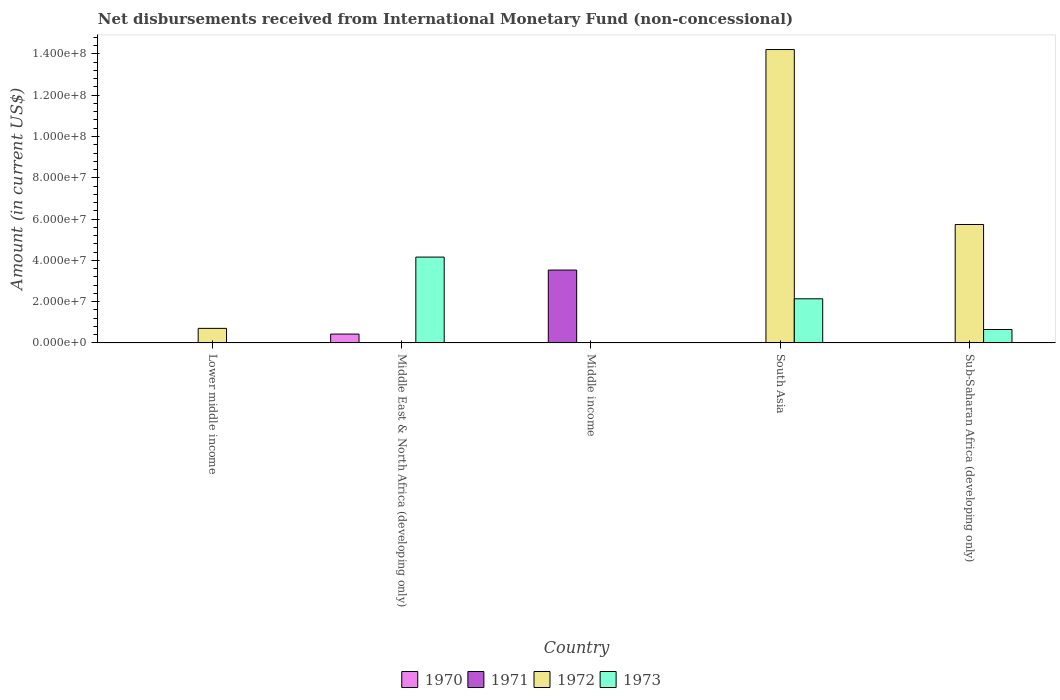How many different coloured bars are there?
Make the answer very short. 4. Are the number of bars on each tick of the X-axis equal?
Provide a short and direct response. No. How many bars are there on the 1st tick from the right?
Provide a succinct answer. 2. What is the label of the 2nd group of bars from the left?
Your response must be concise. Middle East & North Africa (developing only). Across all countries, what is the maximum amount of disbursements received from International Monetary Fund in 1972?
Provide a short and direct response. 1.42e+08. What is the total amount of disbursements received from International Monetary Fund in 1973 in the graph?
Make the answer very short. 6.95e+07. What is the difference between the amount of disbursements received from International Monetary Fund in 1972 in South Asia and that in Sub-Saharan Africa (developing only)?
Ensure brevity in your answer.  8.48e+07. What is the difference between the amount of disbursements received from International Monetary Fund in 1972 in South Asia and the amount of disbursements received from International Monetary Fund in 1970 in Middle income?
Provide a short and direct response. 1.42e+08. What is the average amount of disbursements received from International Monetary Fund in 1971 per country?
Your answer should be very brief. 7.06e+06. What is the difference between the amount of disbursements received from International Monetary Fund of/in 1973 and amount of disbursements received from International Monetary Fund of/in 1970 in Middle East & North Africa (developing only)?
Make the answer very short. 3.73e+07. Is the amount of disbursements received from International Monetary Fund in 1973 in Middle East & North Africa (developing only) less than that in South Asia?
Provide a succinct answer. No. What is the difference between the highest and the second highest amount of disbursements received from International Monetary Fund in 1972?
Give a very brief answer. 8.48e+07. What is the difference between the highest and the lowest amount of disbursements received from International Monetary Fund in 1972?
Provide a succinct answer. 1.42e+08. Is the sum of the amount of disbursements received from International Monetary Fund in 1972 in Lower middle income and South Asia greater than the maximum amount of disbursements received from International Monetary Fund in 1973 across all countries?
Your response must be concise. Yes. Is it the case that in every country, the sum of the amount of disbursements received from International Monetary Fund in 1971 and amount of disbursements received from International Monetary Fund in 1973 is greater than the sum of amount of disbursements received from International Monetary Fund in 1972 and amount of disbursements received from International Monetary Fund in 1970?
Keep it short and to the point. No. Is it the case that in every country, the sum of the amount of disbursements received from International Monetary Fund in 1972 and amount of disbursements received from International Monetary Fund in 1973 is greater than the amount of disbursements received from International Monetary Fund in 1971?
Give a very brief answer. No. How many bars are there?
Your response must be concise. 8. What is the difference between two consecutive major ticks on the Y-axis?
Offer a very short reply. 2.00e+07. Are the values on the major ticks of Y-axis written in scientific E-notation?
Your answer should be very brief. Yes. Does the graph contain any zero values?
Offer a very short reply. Yes. What is the title of the graph?
Make the answer very short. Net disbursements received from International Monetary Fund (non-concessional). Does "1966" appear as one of the legend labels in the graph?
Your response must be concise. No. What is the label or title of the X-axis?
Give a very brief answer. Country. What is the Amount (in current US$) in 1970 in Lower middle income?
Offer a very short reply. 0. What is the Amount (in current US$) in 1971 in Lower middle income?
Your answer should be very brief. 0. What is the Amount (in current US$) of 1972 in Lower middle income?
Ensure brevity in your answer.  7.06e+06. What is the Amount (in current US$) of 1973 in Lower middle income?
Your answer should be very brief. 0. What is the Amount (in current US$) of 1970 in Middle East & North Africa (developing only)?
Your response must be concise. 4.30e+06. What is the Amount (in current US$) of 1973 in Middle East & North Africa (developing only)?
Offer a terse response. 4.16e+07. What is the Amount (in current US$) of 1970 in Middle income?
Provide a short and direct response. 0. What is the Amount (in current US$) of 1971 in Middle income?
Offer a very short reply. 3.53e+07. What is the Amount (in current US$) of 1973 in Middle income?
Your answer should be compact. 0. What is the Amount (in current US$) in 1971 in South Asia?
Your answer should be compact. 0. What is the Amount (in current US$) of 1972 in South Asia?
Offer a very short reply. 1.42e+08. What is the Amount (in current US$) in 1973 in South Asia?
Provide a succinct answer. 2.14e+07. What is the Amount (in current US$) of 1972 in Sub-Saharan Africa (developing only)?
Keep it short and to the point. 5.74e+07. What is the Amount (in current US$) in 1973 in Sub-Saharan Africa (developing only)?
Your answer should be very brief. 6.51e+06. Across all countries, what is the maximum Amount (in current US$) in 1970?
Give a very brief answer. 4.30e+06. Across all countries, what is the maximum Amount (in current US$) of 1971?
Offer a terse response. 3.53e+07. Across all countries, what is the maximum Amount (in current US$) of 1972?
Make the answer very short. 1.42e+08. Across all countries, what is the maximum Amount (in current US$) of 1973?
Provide a succinct answer. 4.16e+07. Across all countries, what is the minimum Amount (in current US$) in 1970?
Provide a short and direct response. 0. Across all countries, what is the minimum Amount (in current US$) of 1972?
Provide a short and direct response. 0. Across all countries, what is the minimum Amount (in current US$) in 1973?
Give a very brief answer. 0. What is the total Amount (in current US$) in 1970 in the graph?
Give a very brief answer. 4.30e+06. What is the total Amount (in current US$) in 1971 in the graph?
Make the answer very short. 3.53e+07. What is the total Amount (in current US$) of 1972 in the graph?
Provide a short and direct response. 2.07e+08. What is the total Amount (in current US$) in 1973 in the graph?
Give a very brief answer. 6.95e+07. What is the difference between the Amount (in current US$) of 1972 in Lower middle income and that in South Asia?
Make the answer very short. -1.35e+08. What is the difference between the Amount (in current US$) of 1972 in Lower middle income and that in Sub-Saharan Africa (developing only)?
Give a very brief answer. -5.03e+07. What is the difference between the Amount (in current US$) of 1973 in Middle East & North Africa (developing only) and that in South Asia?
Offer a terse response. 2.02e+07. What is the difference between the Amount (in current US$) in 1973 in Middle East & North Africa (developing only) and that in Sub-Saharan Africa (developing only)?
Provide a succinct answer. 3.51e+07. What is the difference between the Amount (in current US$) of 1972 in South Asia and that in Sub-Saharan Africa (developing only)?
Provide a succinct answer. 8.48e+07. What is the difference between the Amount (in current US$) of 1973 in South Asia and that in Sub-Saharan Africa (developing only)?
Provide a short and direct response. 1.49e+07. What is the difference between the Amount (in current US$) in 1972 in Lower middle income and the Amount (in current US$) in 1973 in Middle East & North Africa (developing only)?
Offer a very short reply. -3.45e+07. What is the difference between the Amount (in current US$) of 1972 in Lower middle income and the Amount (in current US$) of 1973 in South Asia?
Make the answer very short. -1.43e+07. What is the difference between the Amount (in current US$) in 1972 in Lower middle income and the Amount (in current US$) in 1973 in Sub-Saharan Africa (developing only)?
Your answer should be very brief. 5.46e+05. What is the difference between the Amount (in current US$) of 1970 in Middle East & North Africa (developing only) and the Amount (in current US$) of 1971 in Middle income?
Make the answer very short. -3.10e+07. What is the difference between the Amount (in current US$) in 1970 in Middle East & North Africa (developing only) and the Amount (in current US$) in 1972 in South Asia?
Your response must be concise. -1.38e+08. What is the difference between the Amount (in current US$) of 1970 in Middle East & North Africa (developing only) and the Amount (in current US$) of 1973 in South Asia?
Provide a short and direct response. -1.71e+07. What is the difference between the Amount (in current US$) in 1970 in Middle East & North Africa (developing only) and the Amount (in current US$) in 1972 in Sub-Saharan Africa (developing only)?
Your answer should be compact. -5.31e+07. What is the difference between the Amount (in current US$) of 1970 in Middle East & North Africa (developing only) and the Amount (in current US$) of 1973 in Sub-Saharan Africa (developing only)?
Make the answer very short. -2.21e+06. What is the difference between the Amount (in current US$) in 1971 in Middle income and the Amount (in current US$) in 1972 in South Asia?
Make the answer very short. -1.07e+08. What is the difference between the Amount (in current US$) of 1971 in Middle income and the Amount (in current US$) of 1973 in South Asia?
Provide a short and direct response. 1.39e+07. What is the difference between the Amount (in current US$) of 1971 in Middle income and the Amount (in current US$) of 1972 in Sub-Saharan Africa (developing only)?
Your response must be concise. -2.21e+07. What is the difference between the Amount (in current US$) of 1971 in Middle income and the Amount (in current US$) of 1973 in Sub-Saharan Africa (developing only)?
Give a very brief answer. 2.88e+07. What is the difference between the Amount (in current US$) in 1972 in South Asia and the Amount (in current US$) in 1973 in Sub-Saharan Africa (developing only)?
Your response must be concise. 1.36e+08. What is the average Amount (in current US$) in 1970 per country?
Your answer should be very brief. 8.60e+05. What is the average Amount (in current US$) in 1971 per country?
Your answer should be compact. 7.06e+06. What is the average Amount (in current US$) of 1972 per country?
Keep it short and to the point. 4.13e+07. What is the average Amount (in current US$) of 1973 per country?
Provide a succinct answer. 1.39e+07. What is the difference between the Amount (in current US$) of 1970 and Amount (in current US$) of 1973 in Middle East & North Africa (developing only)?
Offer a very short reply. -3.73e+07. What is the difference between the Amount (in current US$) in 1972 and Amount (in current US$) in 1973 in South Asia?
Your answer should be very brief. 1.21e+08. What is the difference between the Amount (in current US$) in 1972 and Amount (in current US$) in 1973 in Sub-Saharan Africa (developing only)?
Provide a short and direct response. 5.09e+07. What is the ratio of the Amount (in current US$) in 1972 in Lower middle income to that in South Asia?
Your answer should be very brief. 0.05. What is the ratio of the Amount (in current US$) of 1972 in Lower middle income to that in Sub-Saharan Africa (developing only)?
Keep it short and to the point. 0.12. What is the ratio of the Amount (in current US$) of 1973 in Middle East & North Africa (developing only) to that in South Asia?
Provide a succinct answer. 1.94. What is the ratio of the Amount (in current US$) in 1973 in Middle East & North Africa (developing only) to that in Sub-Saharan Africa (developing only)?
Provide a succinct answer. 6.39. What is the ratio of the Amount (in current US$) of 1972 in South Asia to that in Sub-Saharan Africa (developing only)?
Make the answer very short. 2.48. What is the ratio of the Amount (in current US$) of 1973 in South Asia to that in Sub-Saharan Africa (developing only)?
Keep it short and to the point. 3.29. What is the difference between the highest and the second highest Amount (in current US$) in 1972?
Your answer should be compact. 8.48e+07. What is the difference between the highest and the second highest Amount (in current US$) in 1973?
Your answer should be very brief. 2.02e+07. What is the difference between the highest and the lowest Amount (in current US$) in 1970?
Provide a succinct answer. 4.30e+06. What is the difference between the highest and the lowest Amount (in current US$) in 1971?
Keep it short and to the point. 3.53e+07. What is the difference between the highest and the lowest Amount (in current US$) in 1972?
Make the answer very short. 1.42e+08. What is the difference between the highest and the lowest Amount (in current US$) of 1973?
Your answer should be compact. 4.16e+07. 